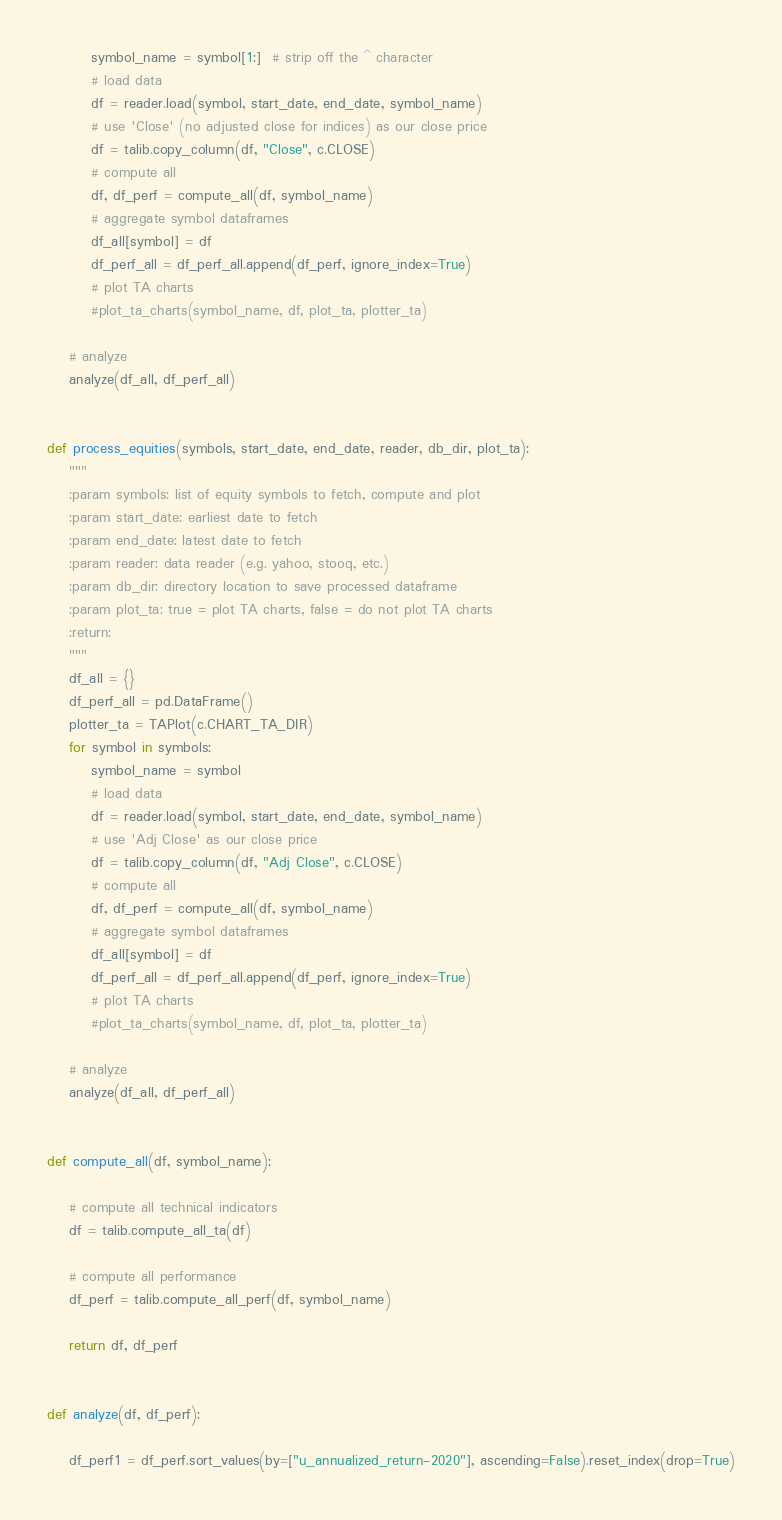<code> <loc_0><loc_0><loc_500><loc_500><_Python_>        symbol_name = symbol[1:]  # strip off the ^ character
        # load data
        df = reader.load(symbol, start_date, end_date, symbol_name)
        # use 'Close' (no adjusted close for indices) as our close price
        df = talib.copy_column(df, "Close", c.CLOSE)
        # compute all
        df, df_perf = compute_all(df, symbol_name)
        # aggregate symbol dataframes
        df_all[symbol] = df
        df_perf_all = df_perf_all.append(df_perf, ignore_index=True)
        # plot TA charts
        #plot_ta_charts(symbol_name, df, plot_ta, plotter_ta)

    # analyze
    analyze(df_all, df_perf_all)


def process_equities(symbols, start_date, end_date, reader, db_dir, plot_ta):
    """
    :param symbols: list of equity symbols to fetch, compute and plot
    :param start_date: earliest date to fetch
    :param end_date: latest date to fetch
    :param reader: data reader (e.g. yahoo, stooq, etc.)
    :param db_dir: directory location to save processed dataframe
    :param plot_ta: true = plot TA charts, false = do not plot TA charts
    :return:
    """
    df_all = {}
    df_perf_all = pd.DataFrame()
    plotter_ta = TAPlot(c.CHART_TA_DIR)
    for symbol in symbols:
        symbol_name = symbol
        # load data
        df = reader.load(symbol, start_date, end_date, symbol_name)
        # use 'Adj Close' as our close price
        df = talib.copy_column(df, "Adj Close", c.CLOSE)
        # compute all
        df, df_perf = compute_all(df, symbol_name)
        # aggregate symbol dataframes
        df_all[symbol] = df
        df_perf_all = df_perf_all.append(df_perf, ignore_index=True)
        # plot TA charts
        #plot_ta_charts(symbol_name, df, plot_ta, plotter_ta)

    # analyze
    analyze(df_all, df_perf_all)


def compute_all(df, symbol_name):

    # compute all technical indicators
    df = talib.compute_all_ta(df)

    # compute all performance
    df_perf = talib.compute_all_perf(df, symbol_name)

    return df, df_perf


def analyze(df, df_perf):

    df_perf1 = df_perf.sort_values(by=["u_annualized_return-2020"], ascending=False).reset_index(drop=True)</code> 